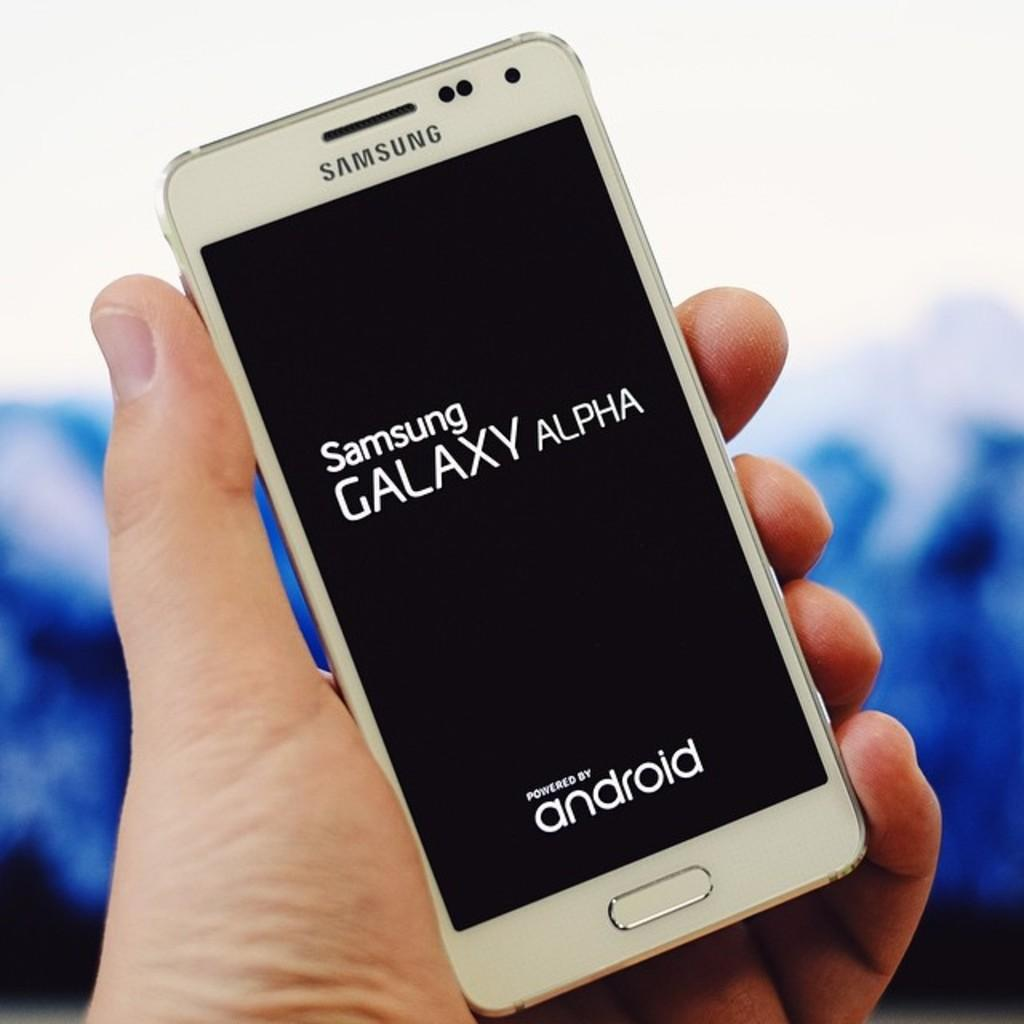<image>
Provide a brief description of the given image. samsung galaxy alpha phone by android a man is holding it 